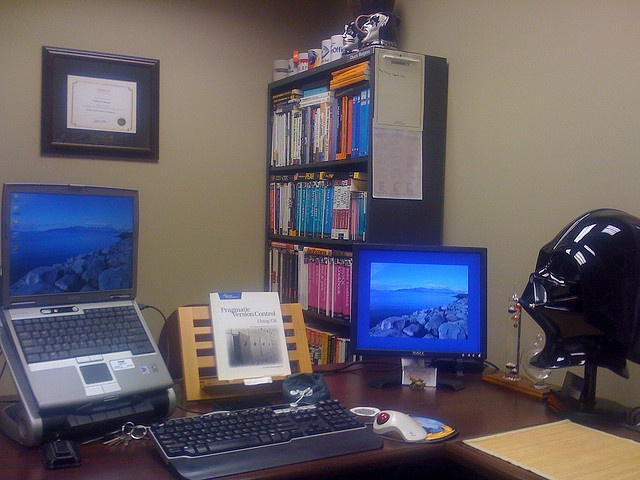Describe the objects in this image and their specific colors. I can see laptop in gray, navy, blue, and darkgray tones, tv in gray, blue, darkblue, and navy tones, keyboard in gray, black, and darkblue tones, book in gray, darkgray, navy, and blue tones, and book in gray, darkgray, blue, and black tones in this image. 